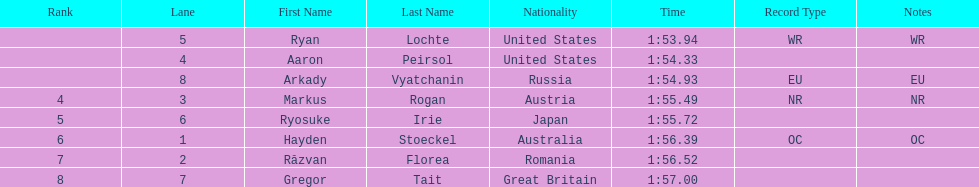How long did it take ryosuke irie to finish? 1:55.72. 